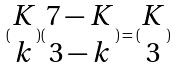<formula> <loc_0><loc_0><loc_500><loc_500>( \begin{matrix} K \\ k \end{matrix} ) ( \begin{matrix} 7 - K \\ 3 - k \end{matrix} ) = ( \begin{matrix} K \\ 3 \end{matrix} )</formula> 